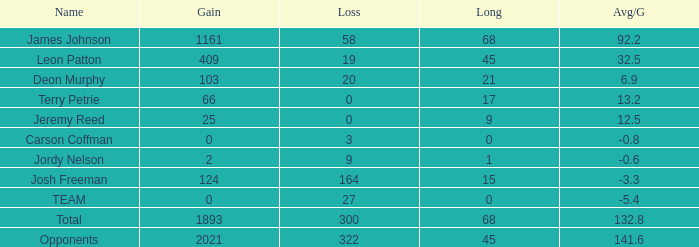What was the number of losses leon patton experienced with the highest gain exceeding 45? 0.0. 